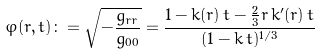Convert formula to latex. <formula><loc_0><loc_0><loc_500><loc_500>\varphi ( r , t ) \colon = \sqrt { - \frac { g _ { r r } } { g _ { 0 0 } } } = \frac { 1 - k ( r ) \, t - \frac { 2 } { 3 } r \, k ^ { \prime } ( r ) \, t } { ( 1 - k \, t ) ^ { 1 / 3 } }</formula> 